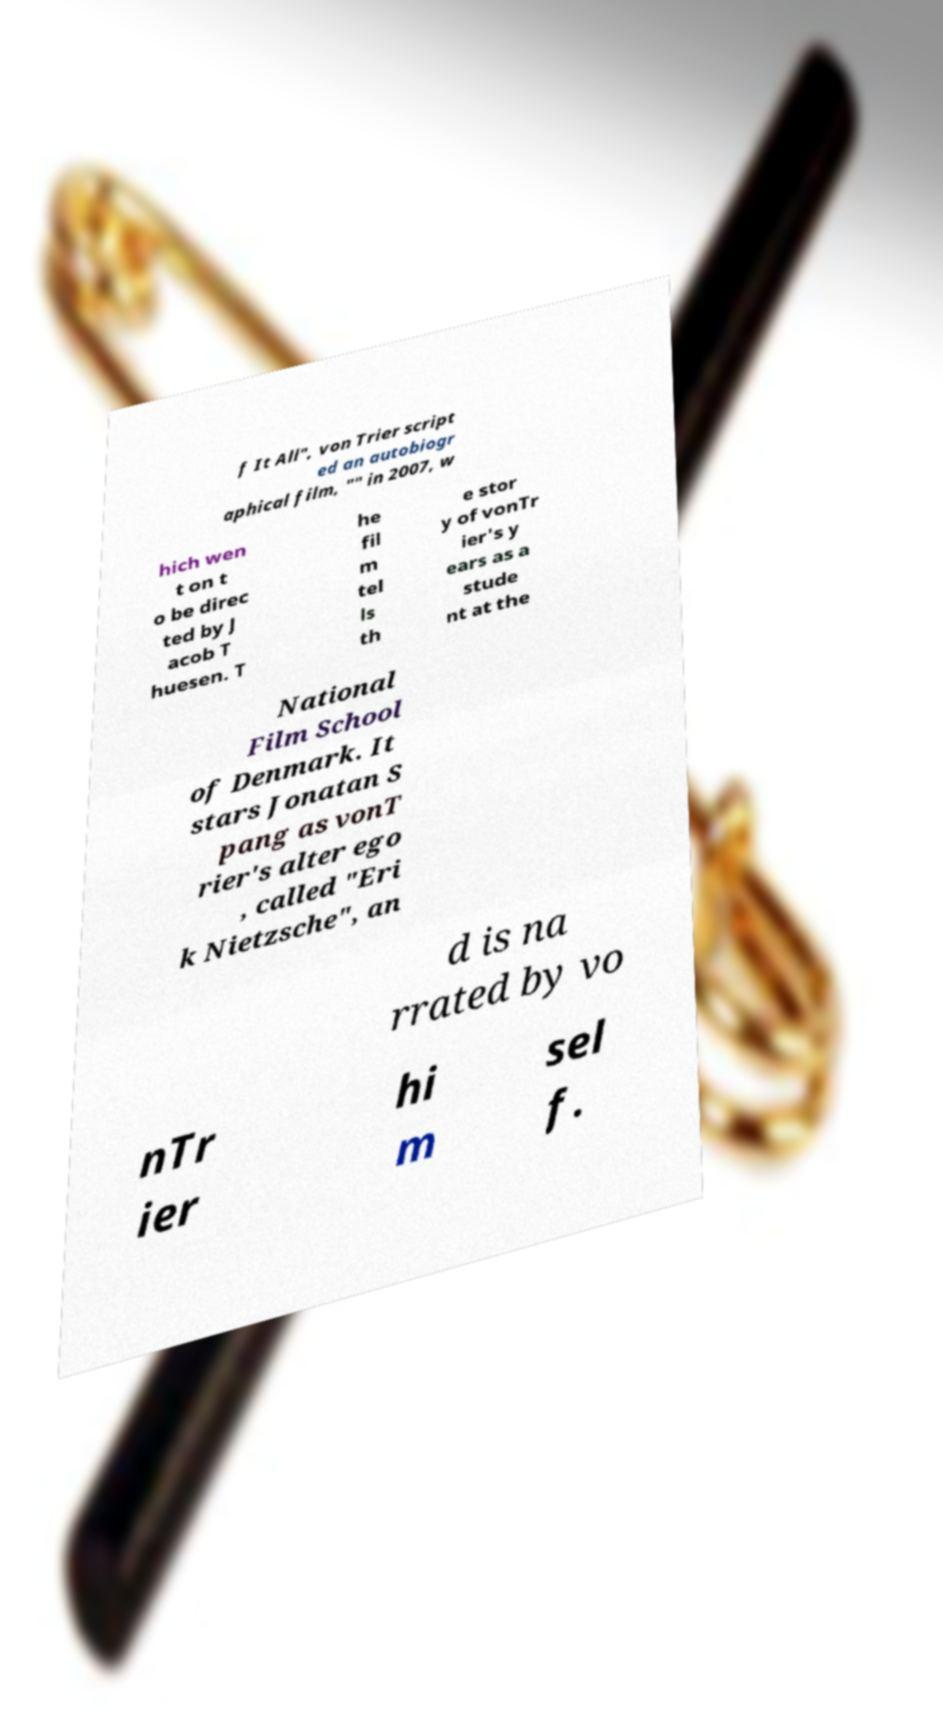Can you read and provide the text displayed in the image?This photo seems to have some interesting text. Can you extract and type it out for me? f It All", von Trier script ed an autobiogr aphical film, "" in 2007, w hich wen t on t o be direc ted by J acob T huesen. T he fil m tel ls th e stor y of vonTr ier's y ears as a stude nt at the National Film School of Denmark. It stars Jonatan S pang as vonT rier's alter ego , called "Eri k Nietzsche", an d is na rrated by vo nTr ier hi m sel f. 